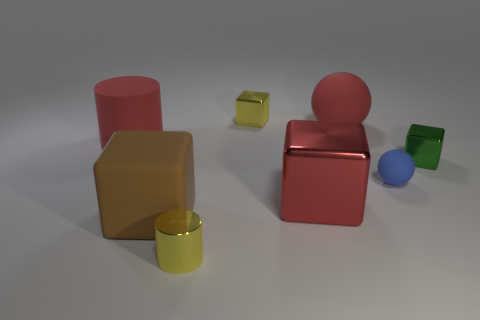The large shiny object that is the same color as the big matte sphere is what shape?
Make the answer very short. Cube. There is a cylinder that is the same color as the large shiny block; what is its material?
Make the answer very short. Rubber. Does the big cylinder have the same color as the large shiny block?
Offer a terse response. Yes. How many other things are there of the same material as the large brown block?
Offer a terse response. 3. There is a big object that is in front of the shiny cube that is in front of the green metallic cube; how many tiny cubes are behind it?
Your answer should be compact. 2. What number of shiny things are either purple objects or cylinders?
Provide a succinct answer. 1. There is a sphere behind the small metal object right of the tiny blue matte object; what is its size?
Provide a short and direct response. Large. There is a large block behind the large brown object; does it have the same color as the sphere that is behind the small matte thing?
Provide a succinct answer. Yes. There is a matte object that is both in front of the large red rubber cylinder and on the right side of the large metallic cube; what color is it?
Your response must be concise. Blue. Is the material of the large brown thing the same as the small green object?
Give a very brief answer. No. 